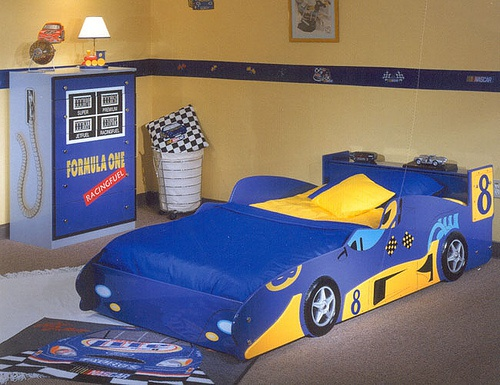Describe the objects in this image and their specific colors. I can see a bed in tan, blue, darkblue, and navy tones in this image. 